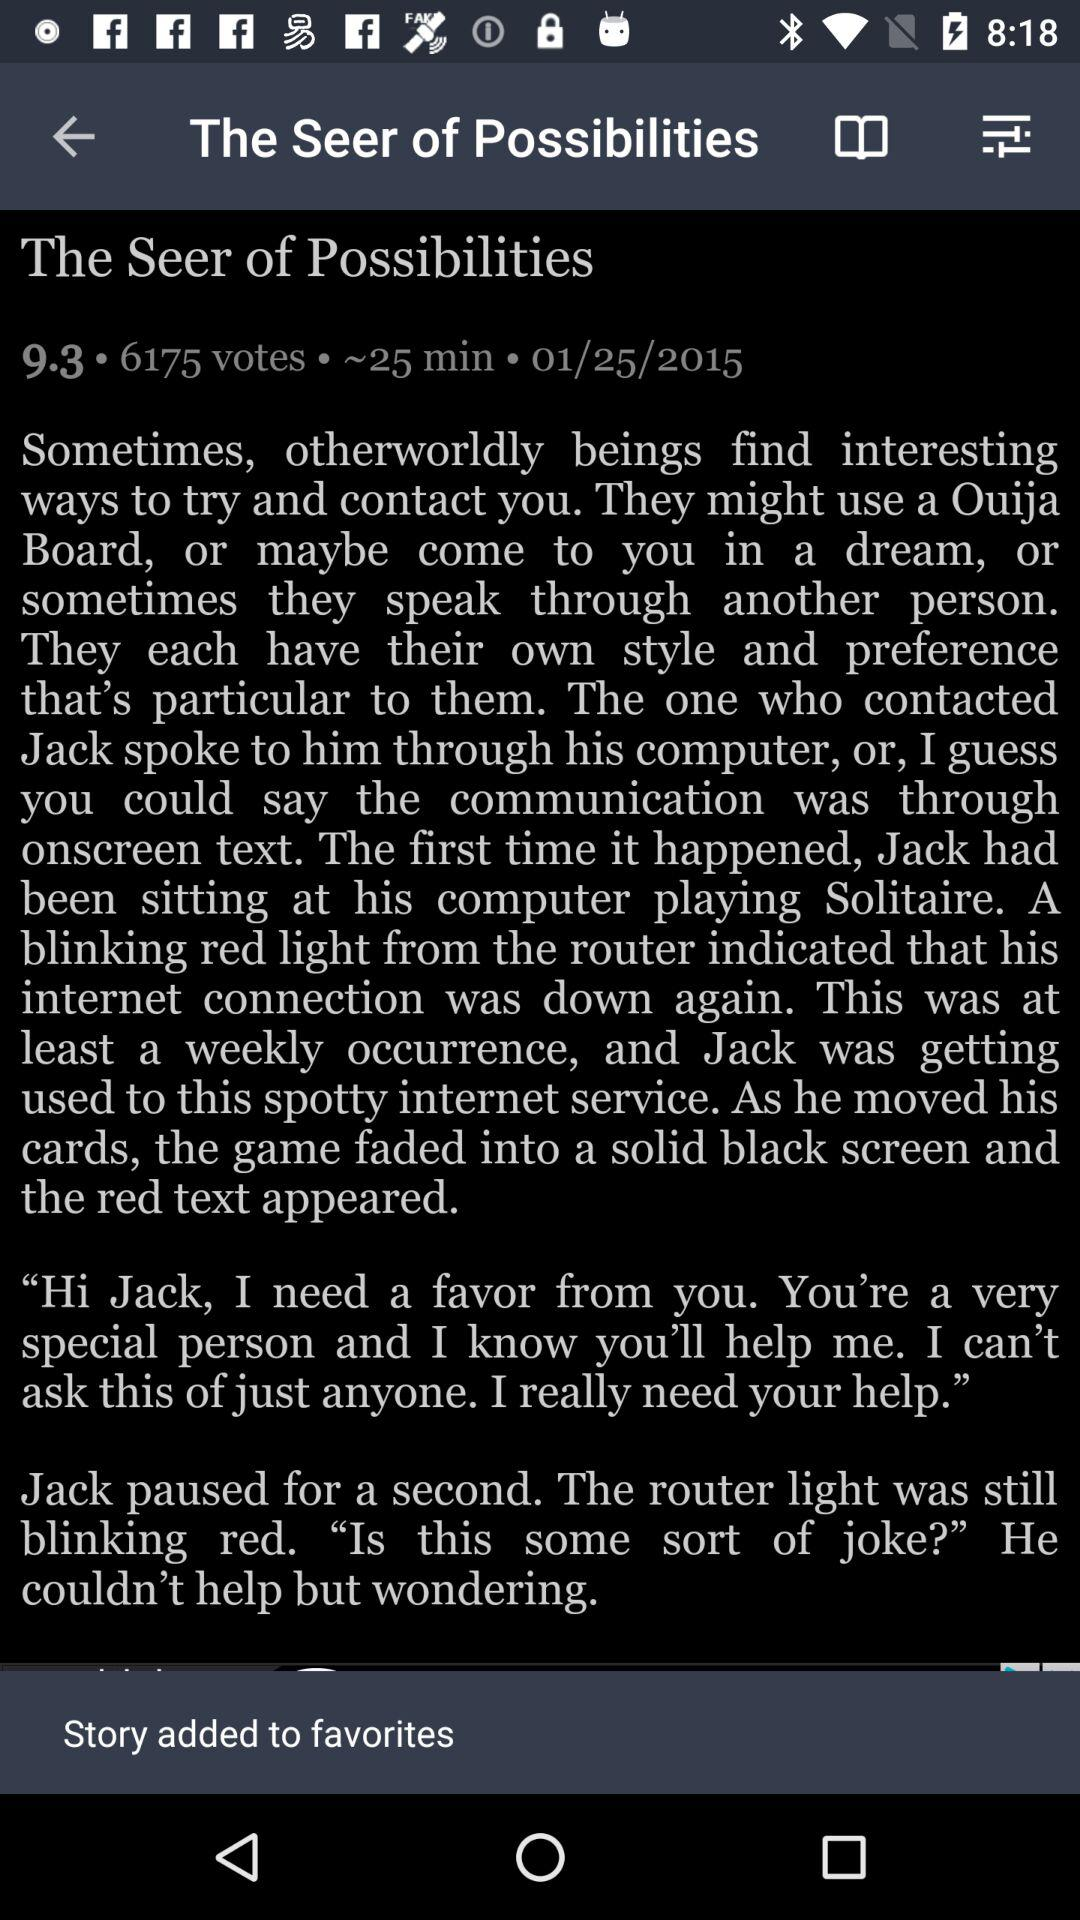How many votes are given to "The Seer of Possibilities"? The number of votes given to "The Seer of Possibilities" is 6175. 